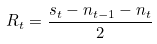Convert formula to latex. <formula><loc_0><loc_0><loc_500><loc_500>R _ { t } = \frac { s _ { t } - n _ { t - 1 } - n _ { t } } { 2 } \,</formula> 